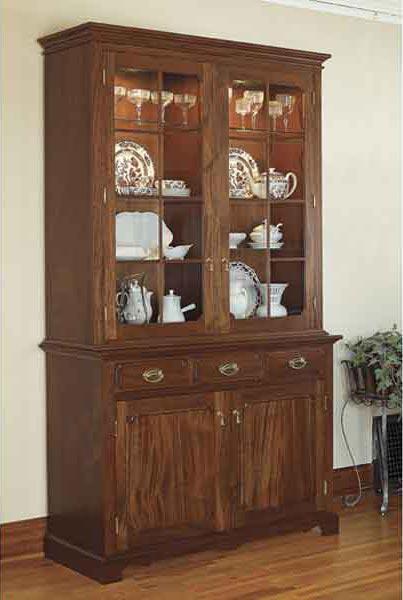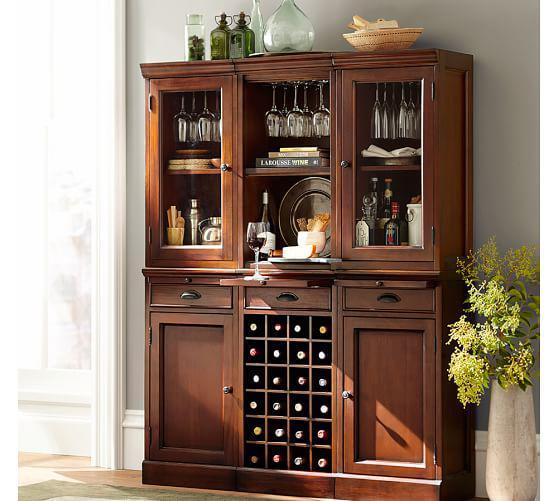The first image is the image on the left, the second image is the image on the right. Given the left and right images, does the statement "The left image features a lighter coloured cabinet with a middle column on its lower half." hold true? Answer yes or no. No. 